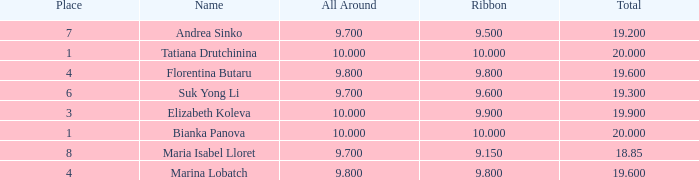What place had a ribbon below 9.8 and a 19.2 total? 7.0. 